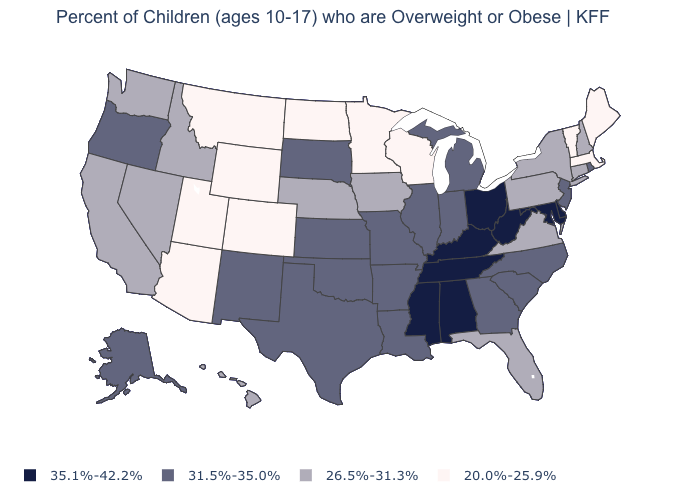Does Maine have the highest value in the USA?
Be succinct. No. Is the legend a continuous bar?
Write a very short answer. No. Among the states that border Oklahoma , does Colorado have the lowest value?
Short answer required. Yes. Name the states that have a value in the range 20.0%-25.9%?
Be succinct. Arizona, Colorado, Maine, Massachusetts, Minnesota, Montana, North Dakota, Utah, Vermont, Wisconsin, Wyoming. Name the states that have a value in the range 35.1%-42.2%?
Answer briefly. Alabama, Delaware, Kentucky, Maryland, Mississippi, Ohio, Tennessee, West Virginia. Which states have the lowest value in the USA?
Quick response, please. Arizona, Colorado, Maine, Massachusetts, Minnesota, Montana, North Dakota, Utah, Vermont, Wisconsin, Wyoming. What is the value of Arkansas?
Quick response, please. 31.5%-35.0%. What is the highest value in the USA?
Short answer required. 35.1%-42.2%. What is the lowest value in states that border West Virginia?
Short answer required. 26.5%-31.3%. Among the states that border Mississippi , does Arkansas have the lowest value?
Keep it brief. Yes. Does the map have missing data?
Be succinct. No. Among the states that border Massachusetts , does Vermont have the lowest value?
Concise answer only. Yes. Name the states that have a value in the range 20.0%-25.9%?
Concise answer only. Arizona, Colorado, Maine, Massachusetts, Minnesota, Montana, North Dakota, Utah, Vermont, Wisconsin, Wyoming. What is the highest value in states that border Rhode Island?
Quick response, please. 26.5%-31.3%. What is the highest value in the USA?
Concise answer only. 35.1%-42.2%. 